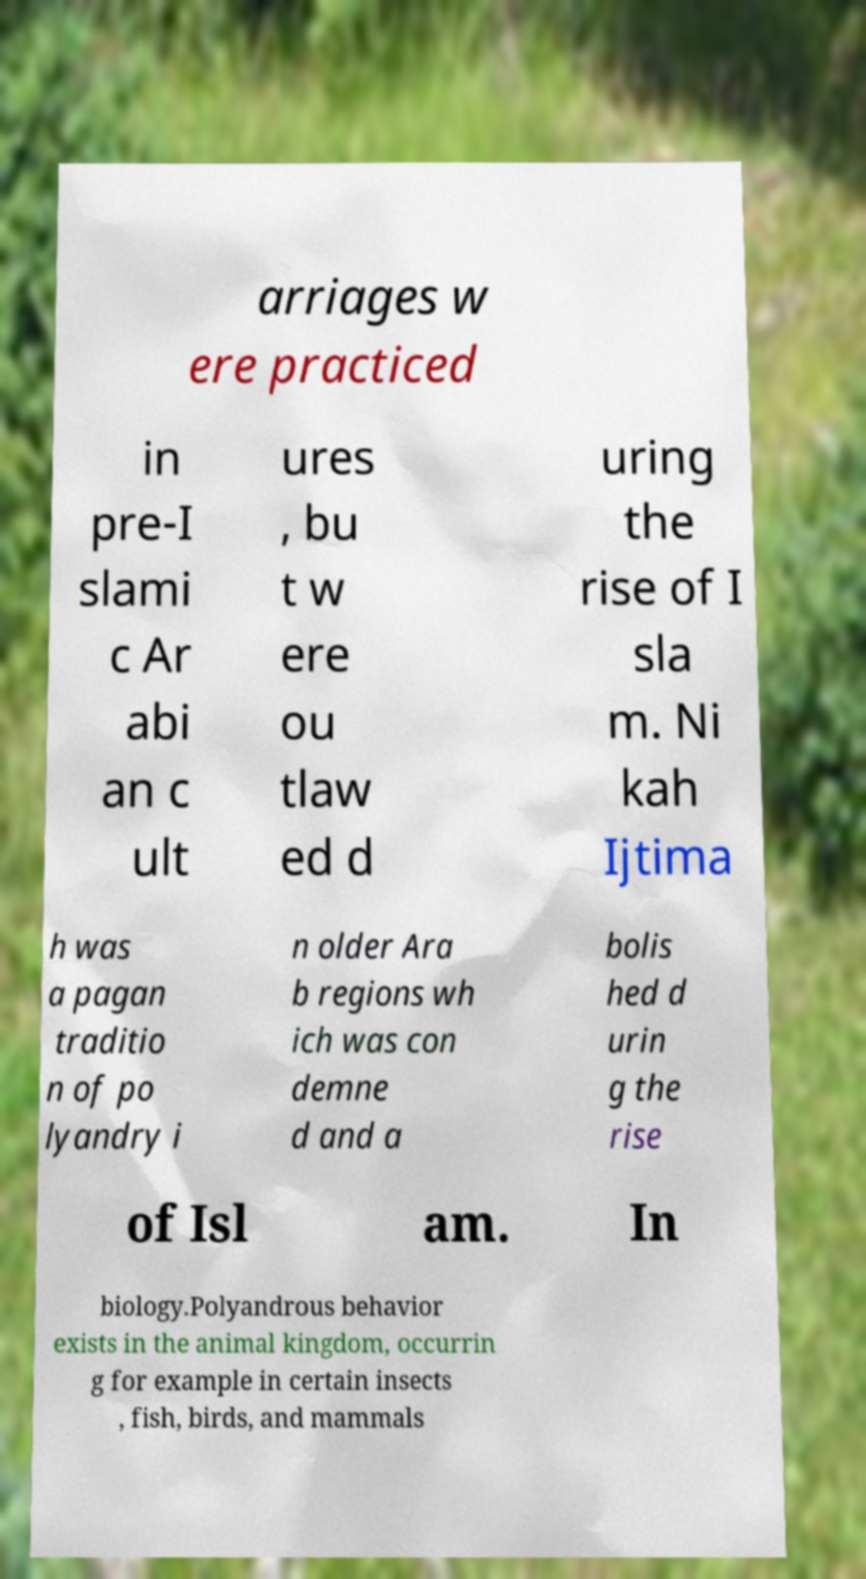For documentation purposes, I need the text within this image transcribed. Could you provide that? arriages w ere practiced in pre-I slami c Ar abi an c ult ures , bu t w ere ou tlaw ed d uring the rise of I sla m. Ni kah Ijtima h was a pagan traditio n of po lyandry i n older Ara b regions wh ich was con demne d and a bolis hed d urin g the rise of Isl am. In biology.Polyandrous behavior exists in the animal kingdom, occurrin g for example in certain insects , fish, birds, and mammals 